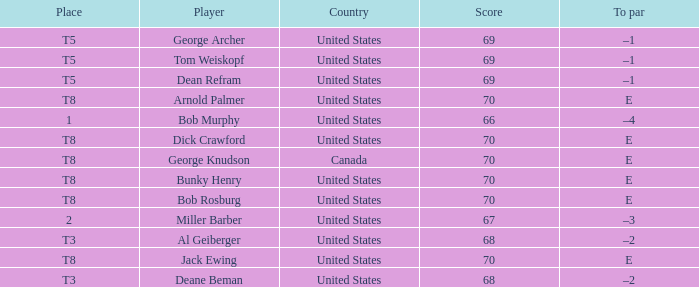When Bunky Henry of the United States scored higher than 67 and his To par was e, what was his place? T8. 